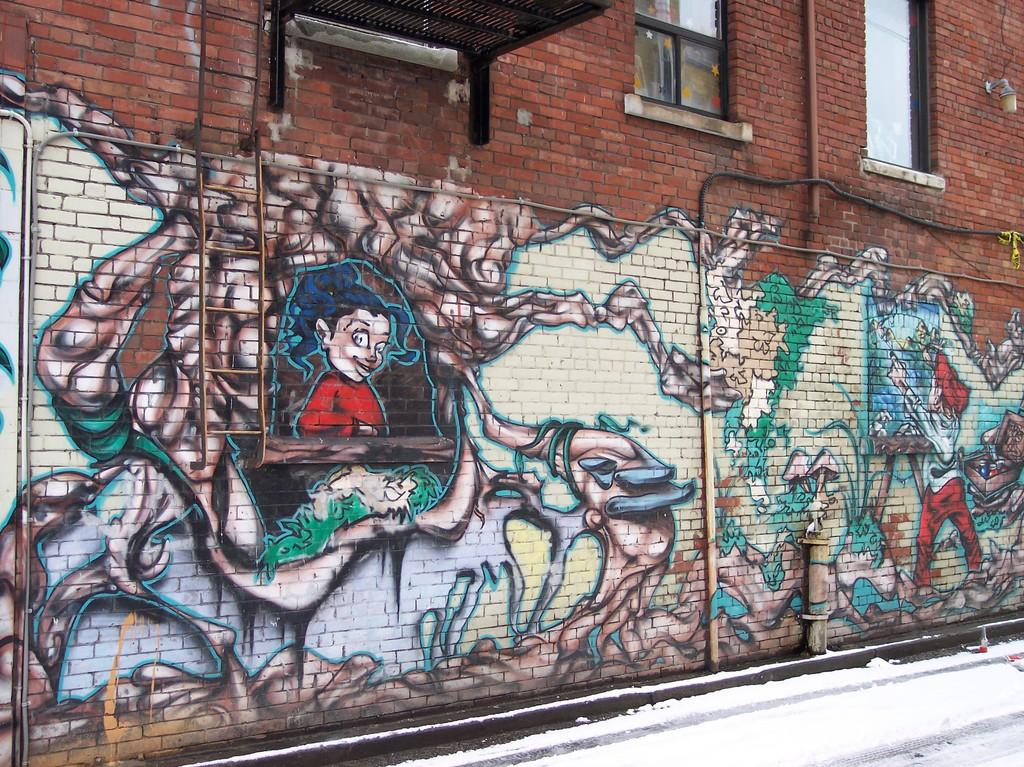What is the main subject in the center of the image? There is a wall in the center of the image. What is depicted on the wall? There is graffiti on the wall. Are there any architectural features visible in the image? Yes, there are windows visible in the image. How does the faucet contribute to the overall design of the graffiti in the image? There is no faucet present in the image, so it cannot contribute to the design of the graffiti. 